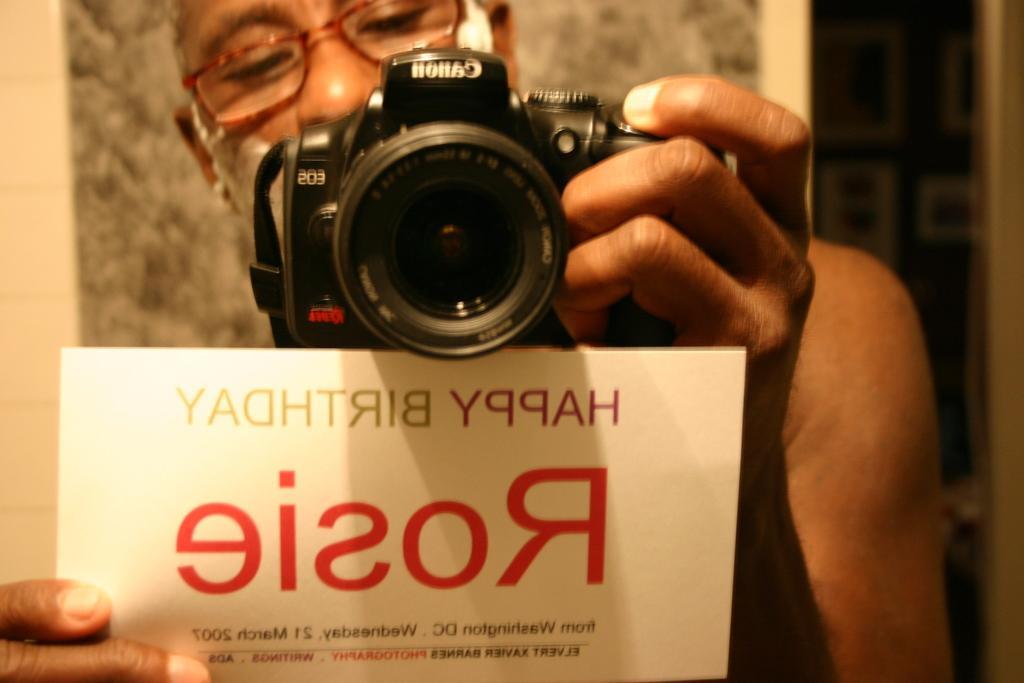Could you give a brief overview of what you see in this image? In this image we can see a person holding a camera in one hand and a paper with the text in the other hand and we can see the image is blurred in the background. 